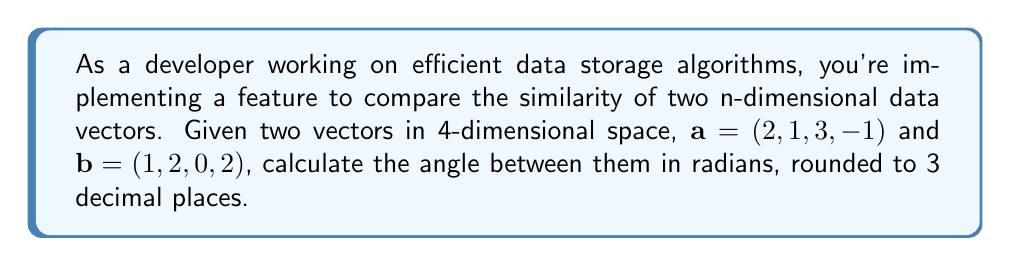Help me with this question. To calculate the angle between two vectors in n-dimensional space, we can use the dot product formula:

$$\cos \theta = \frac{\mathbf{a} \cdot \mathbf{b}}{|\mathbf{a}| |\mathbf{b}|}$$

Where $\theta$ is the angle between the vectors, $\mathbf{a} \cdot \mathbf{b}$ is the dot product, and $|\mathbf{a}|$ and $|\mathbf{b}|$ are the magnitudes of vectors $\mathbf{a}$ and $\mathbf{b}$ respectively.

Step 1: Calculate the dot product $\mathbf{a} \cdot \mathbf{b}$
$$\mathbf{a} \cdot \mathbf{b} = (2)(1) + (1)(2) + (3)(0) + (-1)(2) = 2 + 2 + 0 - 2 = 2$$

Step 2: Calculate the magnitudes $|\mathbf{a}|$ and $|\mathbf{b}|$
$$|\mathbf{a}| = \sqrt{2^2 + 1^2 + 3^2 + (-1)^2} = \sqrt{4 + 1 + 9 + 1} = \sqrt{15}$$
$$|\mathbf{b}| = \sqrt{1^2 + 2^2 + 0^2 + 2^2} = \sqrt{1 + 4 + 0 + 4} = 3$$

Step 3: Apply the dot product formula
$$\cos \theta = \frac{2}{\sqrt{15} \cdot 3} = \frac{2}{3\sqrt{15}}$$

Step 4: Take the inverse cosine (arccos) of both sides
$$\theta = \arccos\left(\frac{2}{3\sqrt{15}}\right)$$

Step 5: Calculate the result and round to 3 decimal places
$$\theta \approx 1.249 \text{ radians}$$
Answer: $1.249 \text{ radians}$ 